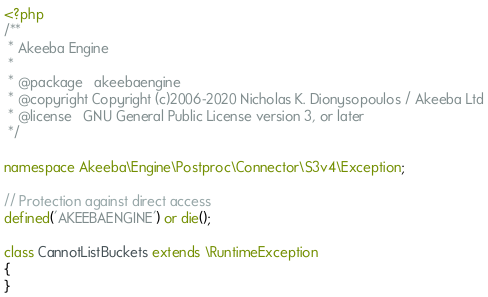<code> <loc_0><loc_0><loc_500><loc_500><_PHP_><?php
/**
 * Akeeba Engine
 *
 * @package   akeebaengine
 * @copyright Copyright (c)2006-2020 Nicholas K. Dionysopoulos / Akeeba Ltd
 * @license   GNU General Public License version 3, or later
 */

namespace Akeeba\Engine\Postproc\Connector\S3v4\Exception;

// Protection against direct access
defined('AKEEBAENGINE') or die();

class CannotListBuckets extends \RuntimeException
{
}
</code> 